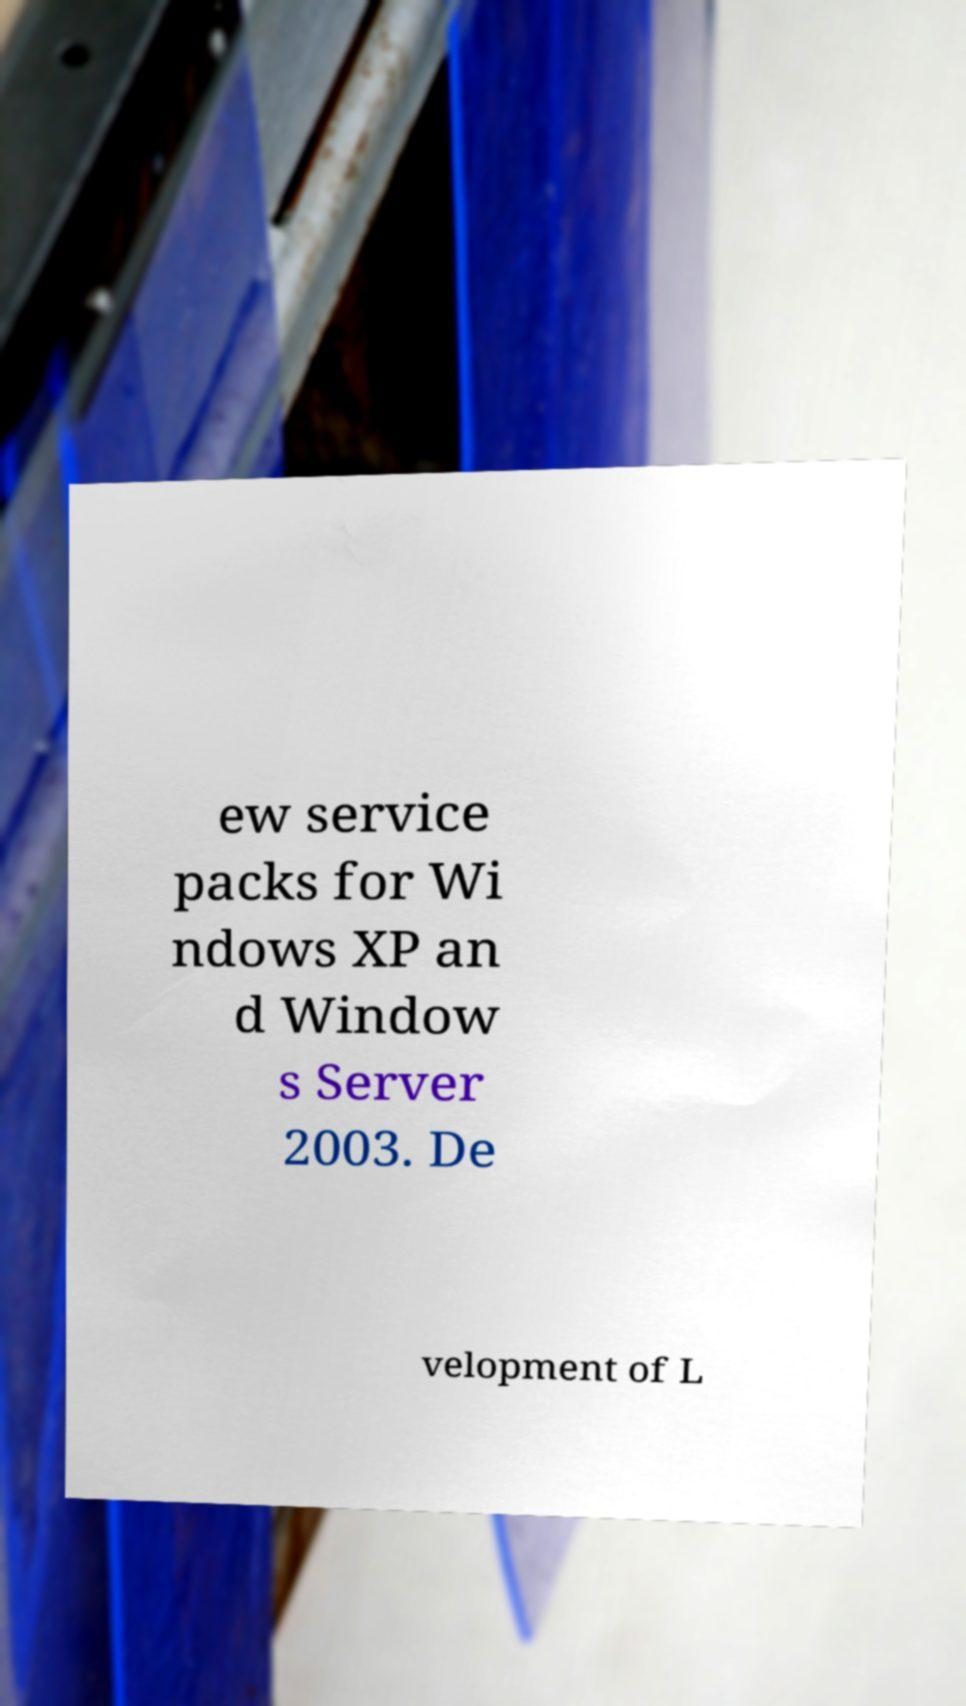Could you assist in decoding the text presented in this image and type it out clearly? ew service packs for Wi ndows XP an d Window s Server 2003. De velopment of L 